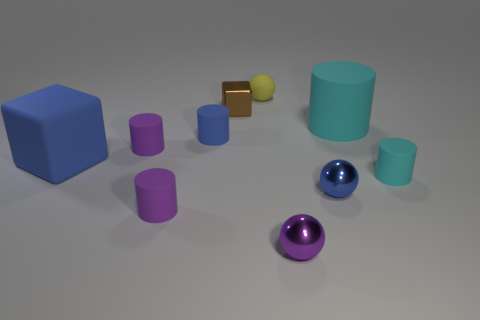What can you infer about the light source in this picture? The lighting in the image appears to be diffused, with soft shadows cast under each object, suggesting the light source is not directly overhead but possibly angled. The gentle highlights on the objects, especially on the shiny spheres and metallic rectangles, indicate a well-lit environment, likely with a single, broad light source.  How would changing the light position affect the look of this scene? Altering the light position could dramatically change the scene's ambiance. A higher angle would shorten the shadows and increase the contrast between light and dark areas, emphasizing the three-dimensionality of the objects. A lower angle might elongate the shadows, creating a more dramatic effect, and possibly change the way certain textures, like the matte cyan cylinder and the metallic bars, interact with the light by highlighting their surfaces differently. 